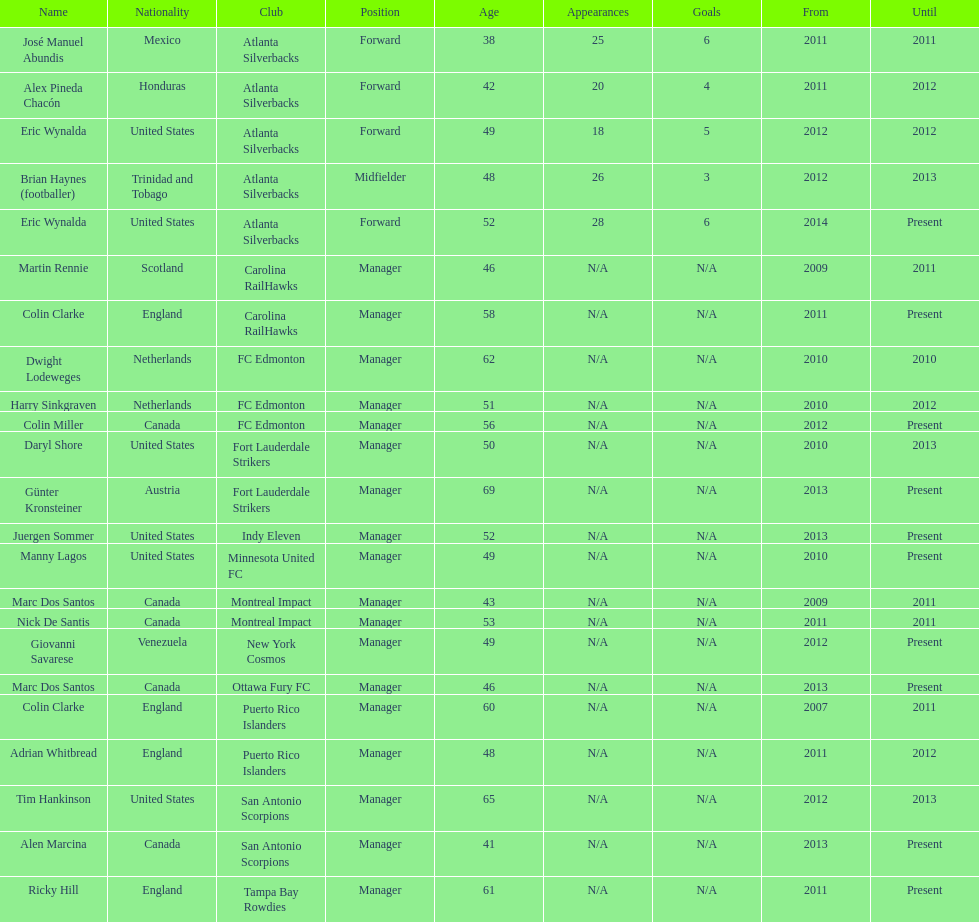How long did colin clarke coach the puerto rico islanders? 4 years. 